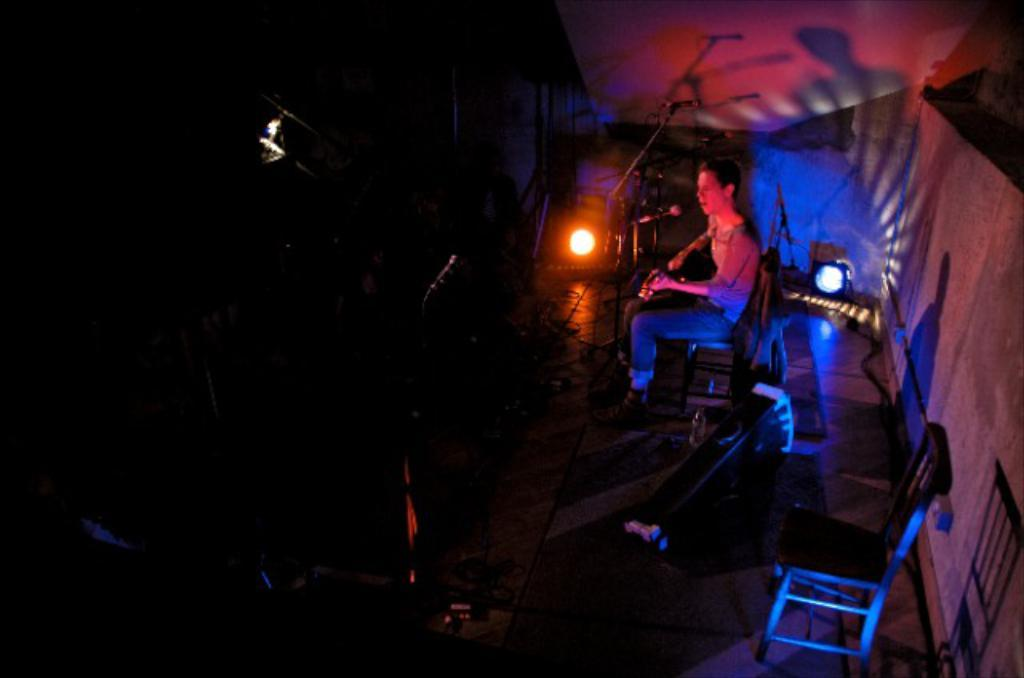What is the man in the image doing? The man is playing a guitar and singing into a microphone. What other objects related to music can be seen in the image? There are musical instruments in the image. Can you describe the lighting in the image? Yes, there is lighting present in the image. How many apples are on the oven in the image? There is no oven or apples present in the image. 